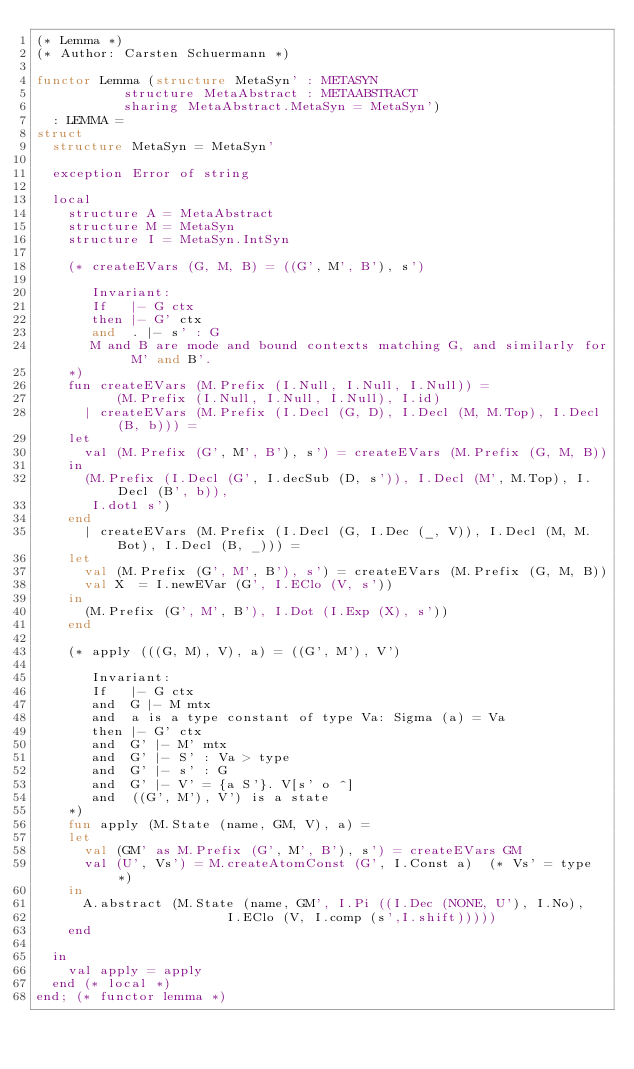<code> <loc_0><loc_0><loc_500><loc_500><_SML_>(* Lemma *)
(* Author: Carsten Schuermann *)

functor Lemma (structure MetaSyn' : METASYN
	       structure MetaAbstract : METAABSTRACT
	       sharing MetaAbstract.MetaSyn = MetaSyn') 
  : LEMMA =
struct
  structure MetaSyn = MetaSyn'

  exception Error of string

  local
    structure A = MetaAbstract
    structure M = MetaSyn
    structure I = MetaSyn.IntSyn

    (* createEVars (G, M, B) = ((G', M', B'), s')
       
       Invariant:
       If   |- G ctx    
       then |- G' ctx 
       and  . |- s' : G
       M and B are mode and bound contexts matching G, and similarly for M' and B'.
    *)
    fun createEVars (M.Prefix (I.Null, I.Null, I.Null)) = 
          (M.Prefix (I.Null, I.Null, I.Null), I.id)
      | createEVars (M.Prefix (I.Decl (G, D), I.Decl (M, M.Top), I.Decl (B, b))) =
	let 
	  val (M.Prefix (G', M', B'), s') = createEVars (M.Prefix (G, M, B))
	in 
	  (M.Prefix (I.Decl (G', I.decSub (D, s')), I.Decl (M', M.Top), I.Decl (B', b)),
	   I.dot1 s')
	end
      | createEVars (M.Prefix (I.Decl (G, I.Dec (_, V)), I.Decl (M, M.Bot), I.Decl (B, _))) =
	let 
	  val (M.Prefix (G', M', B'), s') = createEVars (M.Prefix (G, M, B))
	  val X  = I.newEVar (G', I.EClo (V, s'))
	in
	  (M.Prefix (G', M', B'), I.Dot (I.Exp (X), s'))
	end

    (* apply (((G, M), V), a) = ((G', M'), V')

       Invariant:
       If   |- G ctx
       and  G |- M mtx
       and  a is a type constant of type Va: Sigma (a) = Va
       then |- G' ctx
       and  G' |- M' mtx
       and  G' |- S' : Va > type
       and  G' |- s' : G
       and  G' |- V' = {a S'}. V[s' o ^]
       and  ((G', M'), V') is a state
    *)
    fun apply (M.State (name, GM, V), a) =  
	let 
	  val (GM' as M.Prefix (G', M', B'), s') = createEVars GM
	  val (U', Vs') = M.createAtomConst (G', I.Const a)  (* Vs' = type *) 
	in
	  A.abstract (M.State (name, GM', I.Pi ((I.Dec (NONE, U'), I.No), 
						I.EClo (V, I.comp (s',I.shift)))))
	end
    
  in 
    val apply = apply
  end (* local *)
end; (* functor lemma *)
</code> 